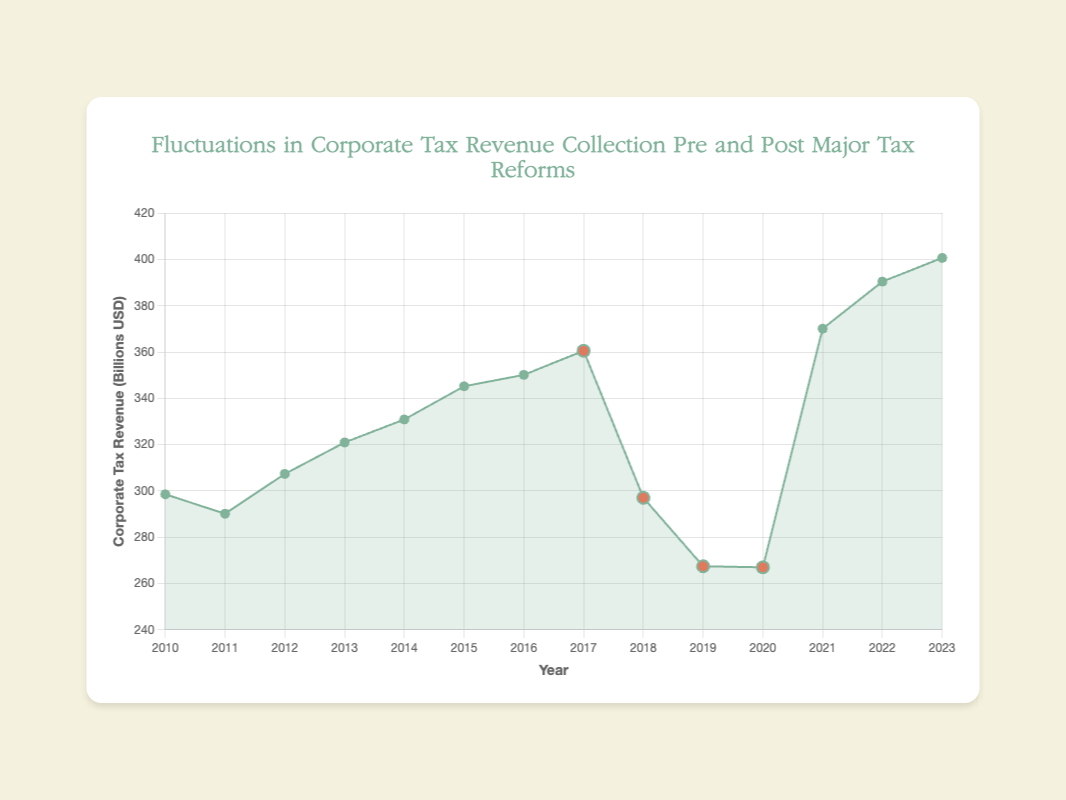what is the highest corporate tax revenue in the dataset? By comparing the tax revenue values from each year, the highest corporate tax revenue is found to be in 2023, with a value of 400.68 billion USD.
Answer: 400.68 billion USD How does the corporate tax revenue in 2019 compare to the revenue in 2016? Comparing the values visually, the corporate tax revenue in 2019 (267.45 billion USD) is lower than the revenue in 2016 (350.14 billion USD).
Answer: Lower What was the change in corporate tax revenue immediately following the Tax Cuts and Jobs Act in 2017? The corporate tax revenue in 2017 was 360.55 billion USD. In 2018, it dropped to 297.04 billion USD. The change is calculated as 297.04 - 360.55 = -63.51 billion USD.
Answer: -63.51 billion USD What is the average corporate tax revenue for the years 2011 to 2013? The tax revenues for 2011, 2012, and 2013 are 290.14, 307.34, and 320.94 billion USD, respectively. Average = (290.14 + 307.34 + 320.94) / 3 = 306.14 billion USD.
Answer: 306.14 billion USD How did the corporate tax revenue change from 2020 to 2021? The tax revenue in 2020 was 267.00 billion USD, and in 2021 it was 370.10 billion USD. The difference is 370.10 - 267.00 = 103.10 billion USD.
Answer: Increased by 103.10 billion USD Which year experienced the lowest corporate tax revenue collection, and what was the value? The minimum tax revenue value is in 2020, with a collection of 267.00 billion USD.
Answer: 2020, 267.00 billion USD What was the impact of the Tax Cuts and Jobs Act on corporate tax revenue in 2018 compared to 2017? The corporate tax revenue decreased from 360.55 billion USD in 2017 to 297.04 billion USD in 2018 due to the Tax Cuts and Jobs Act. This is a decrease of 360.55 - 297.04 = 63.51 billion USD.
Answer: Decreased by 63.51 billion USD What is the trend in corporate tax revenue from 2021 to 2023? The corporate tax revenue shows an increasing trend from 370.10 billion USD in 2021, to 390.45 billion USD in 2022, and 400.68 billion USD in 2023.
Answer: Increasing trend Based on the color and size, which years are marked as having undergone major tax reforms? The years marked in a different color and with larger markers indicate tax reforms: 2017, 2018, 2019, and 2020.
Answer: 2017, 2018, 2019, 2020 What is the difference in corporate tax revenue between the highest and lowest points in the dataset? The highest tax revenue is 400.68 billion USD (2023) and the lowest is 267.00 billion USD (2020). The difference is 400.68 - 267.00 = 133.68 billion USD.
Answer: 133.68 billion USD 